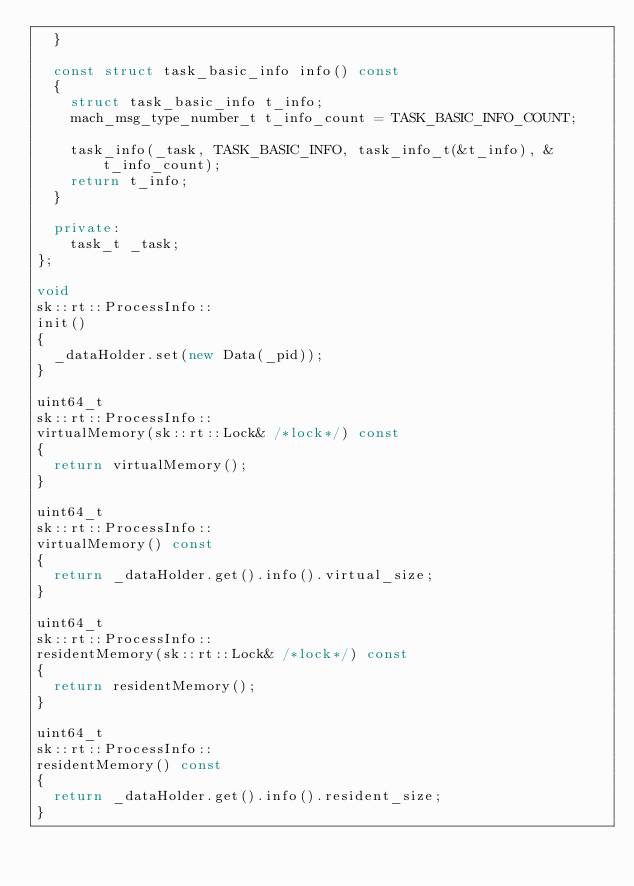<code> <loc_0><loc_0><loc_500><loc_500><_C++_>  }

  const struct task_basic_info info() const
  {
    struct task_basic_info t_info;
    mach_msg_type_number_t t_info_count = TASK_BASIC_INFO_COUNT;

    task_info(_task, TASK_BASIC_INFO, task_info_t(&t_info), &t_info_count);
    return t_info;
  }

  private:
    task_t _task;
};

void
sk::rt::ProcessInfo::
init()
{
  _dataHolder.set(new Data(_pid));
}

uint64_t
sk::rt::ProcessInfo::
virtualMemory(sk::rt::Lock& /*lock*/) const
{
  return virtualMemory();
}

uint64_t
sk::rt::ProcessInfo::
virtualMemory() const
{
  return _dataHolder.get().info().virtual_size;
}

uint64_t
sk::rt::ProcessInfo::
residentMemory(sk::rt::Lock& /*lock*/) const
{
  return residentMemory();
}

uint64_t
sk::rt::ProcessInfo::
residentMemory() const
{
  return _dataHolder.get().info().resident_size;
}
</code> 